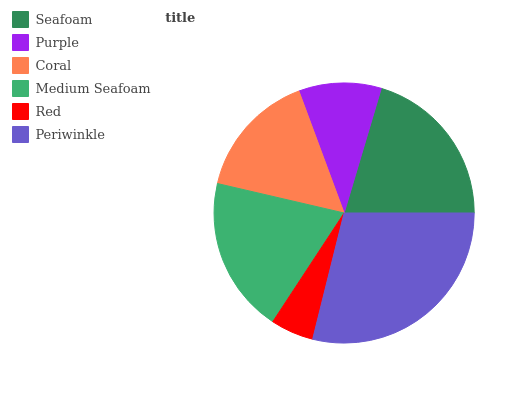Is Red the minimum?
Answer yes or no. Yes. Is Periwinkle the maximum?
Answer yes or no. Yes. Is Purple the minimum?
Answer yes or no. No. Is Purple the maximum?
Answer yes or no. No. Is Seafoam greater than Purple?
Answer yes or no. Yes. Is Purple less than Seafoam?
Answer yes or no. Yes. Is Purple greater than Seafoam?
Answer yes or no. No. Is Seafoam less than Purple?
Answer yes or no. No. Is Medium Seafoam the high median?
Answer yes or no. Yes. Is Coral the low median?
Answer yes or no. Yes. Is Coral the high median?
Answer yes or no. No. Is Seafoam the low median?
Answer yes or no. No. 